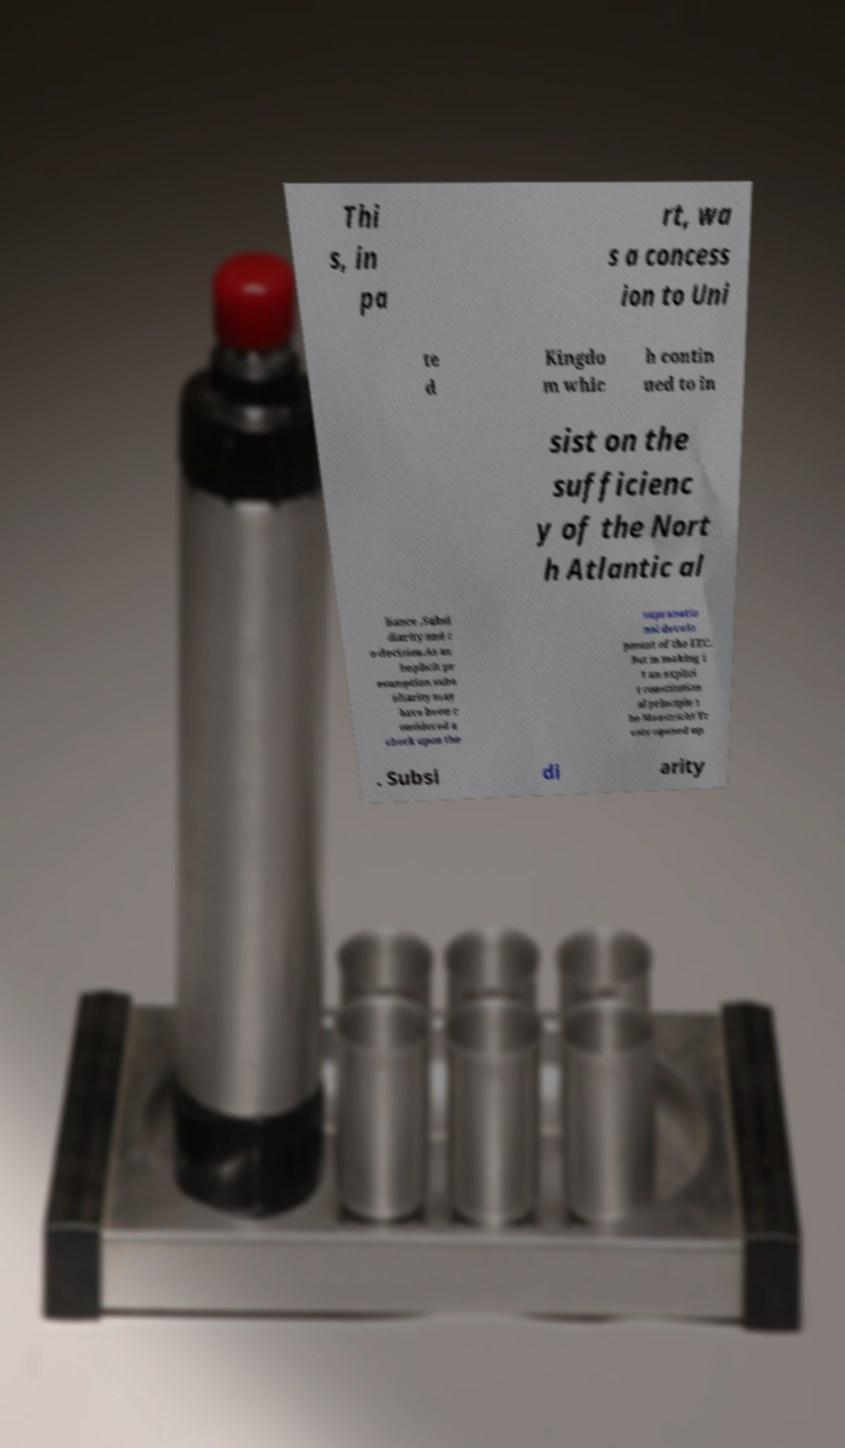Could you extract and type out the text from this image? Thi s, in pa rt, wa s a concess ion to Uni te d Kingdo m whic h contin ued to in sist on the sufficienc y of the Nort h Atlantic al liance ,Subsi diarity and c o-decision.As an implicit pr esumption subs idiarity may have been c onsidered a check upon the supranatio nal develo pment of the EEC. But in making i t an explici t constitution al principle t he Maastricht Tr eaty opened up . Subsi di arity 